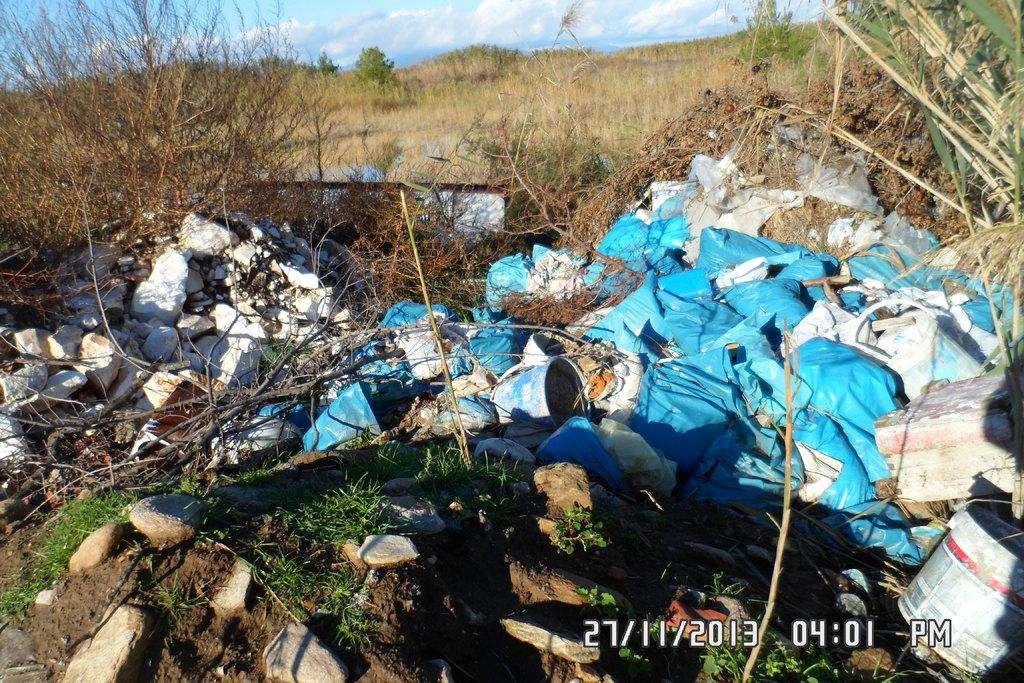What objects are located in the foreground of the image? There are bags, buckets, and stones in the foreground of the image. What type of vegetation can be seen in the background of the image? There are trees in the background of the image. What is visible at the top of the image? The sky is visible at the top of the image. What can be observed in the sky? There are clouds in the sky. How many cows are grazing in the image? There are no cows present in the image. What type of test is being conducted in the image? There is no test being conducted in the image. 